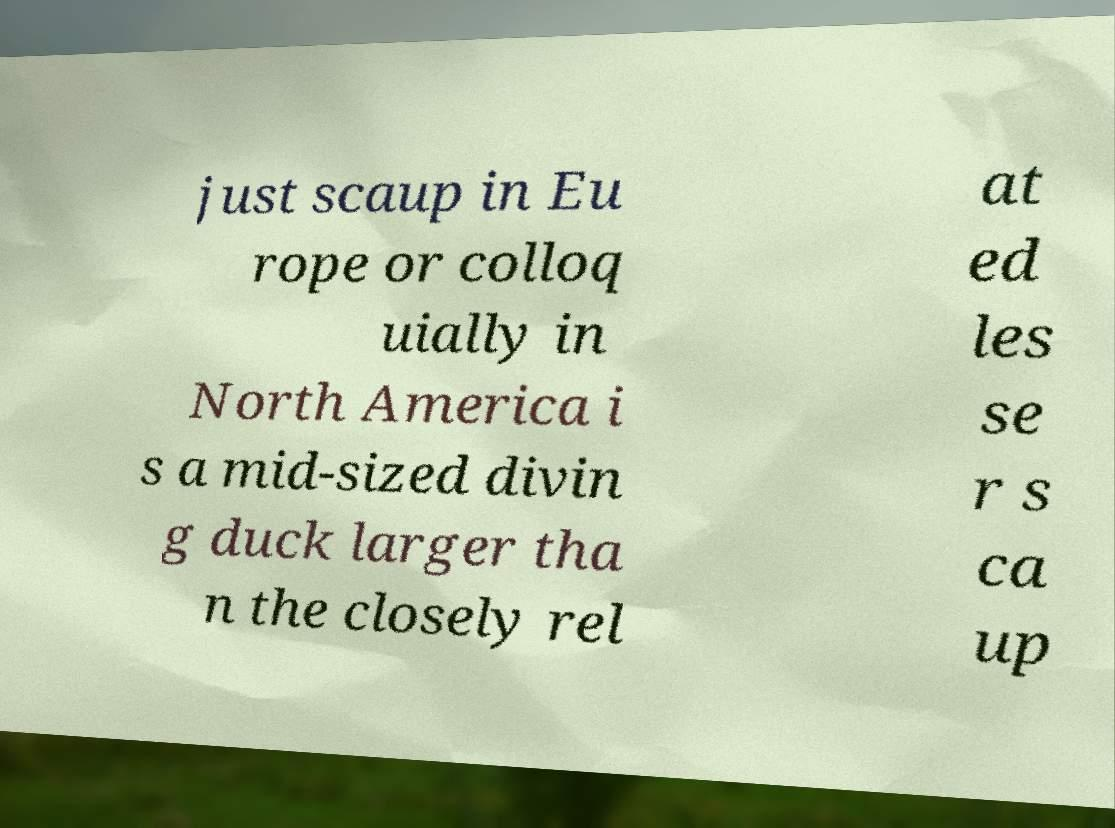Can you accurately transcribe the text from the provided image for me? just scaup in Eu rope or colloq uially in North America i s a mid-sized divin g duck larger tha n the closely rel at ed les se r s ca up 